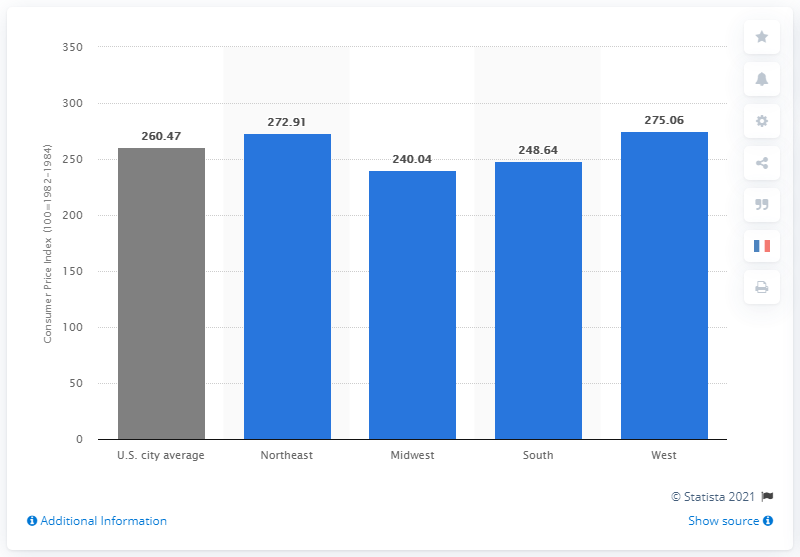Identify some key points in this picture. In 2020, the Consumer Price Index (CPI) in the Western United States was 275.06. 